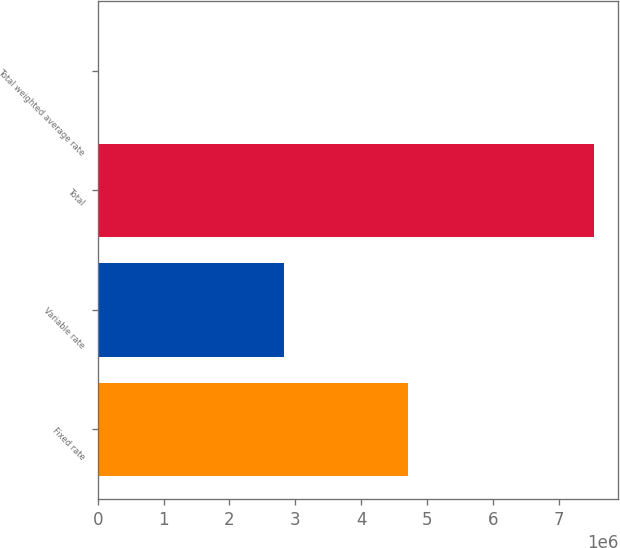<chart> <loc_0><loc_0><loc_500><loc_500><bar_chart><fcel>Fixed rate<fcel>Variable rate<fcel>Total<fcel>Total weighted average rate<nl><fcel>4.70499e+06<fcel>2.82232e+06<fcel>7.5273e+06<fcel>6.08<nl></chart> 